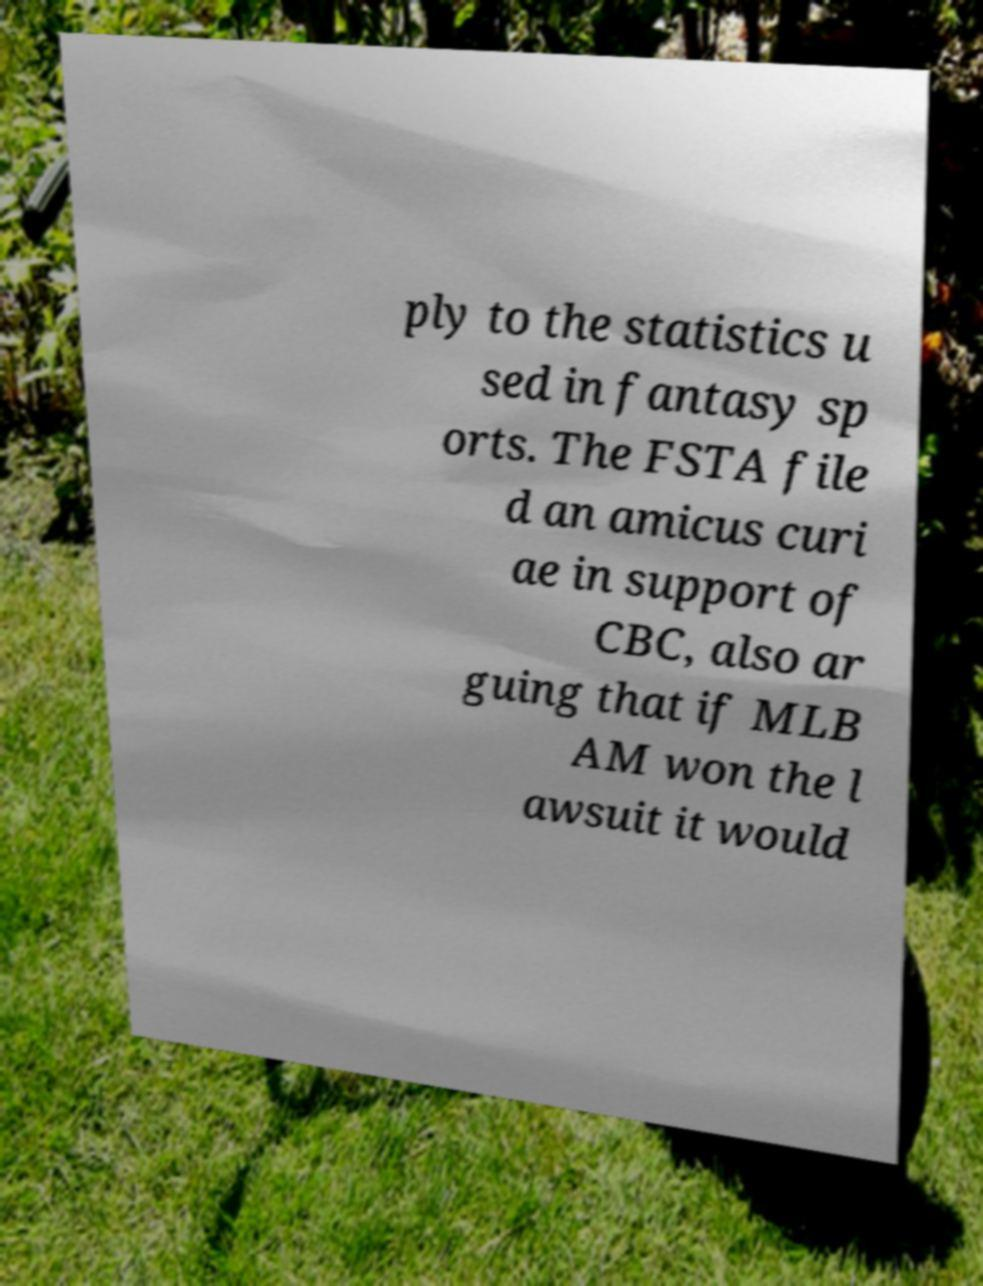Can you accurately transcribe the text from the provided image for me? ply to the statistics u sed in fantasy sp orts. The FSTA file d an amicus curi ae in support of CBC, also ar guing that if MLB AM won the l awsuit it would 